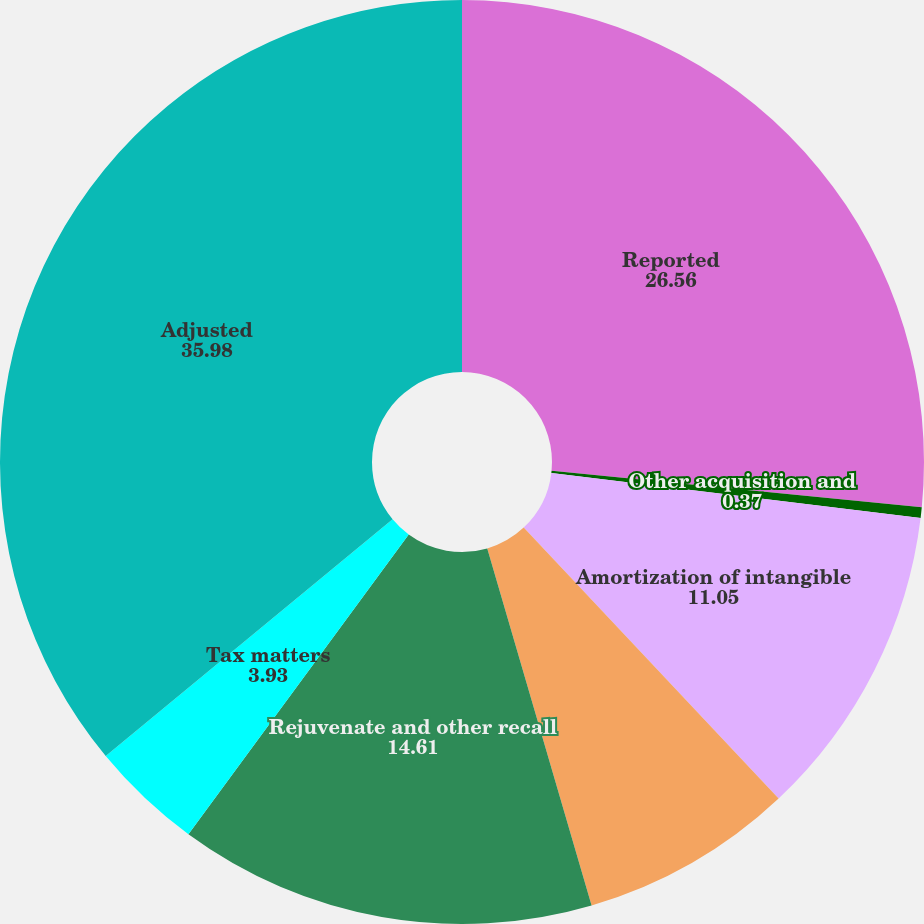<chart> <loc_0><loc_0><loc_500><loc_500><pie_chart><fcel>Reported<fcel>Other acquisition and<fcel>Amortization of intangible<fcel>Restructuring- related charges<fcel>Rejuvenate and other recall<fcel>Tax matters<fcel>Adjusted<nl><fcel>26.56%<fcel>0.37%<fcel>11.05%<fcel>7.49%<fcel>14.61%<fcel>3.93%<fcel>35.98%<nl></chart> 